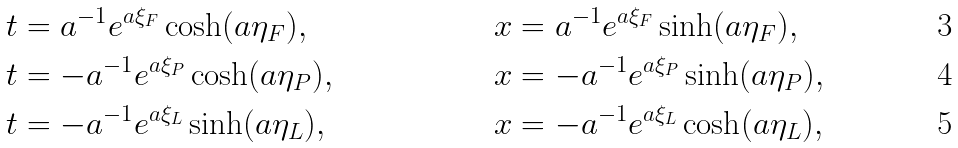<formula> <loc_0><loc_0><loc_500><loc_500>t & = a ^ { - 1 } e ^ { a \xi _ { F } } \cosh ( a \eta _ { F } ) , & \quad x & = a ^ { - 1 } e ^ { a \xi _ { F } } \sinh ( a \eta _ { F } ) , \\ t & = - a ^ { - 1 } e ^ { a \xi _ { P } } \cosh ( a \eta _ { P } ) , & \quad x & = - a ^ { - 1 } e ^ { a \xi _ { P } } \sinh ( a \eta _ { P } ) , \\ t & = - a ^ { - 1 } e ^ { a \xi _ { L } } \sinh ( a \eta _ { L } ) , & \quad x & = - a ^ { - 1 } e ^ { a \xi _ { L } } \cosh ( a \eta _ { L } ) ,</formula> 